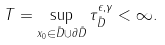<formula> <loc_0><loc_0><loc_500><loc_500>T = \sup _ { x _ { 0 } \in \tilde { D } \cup \partial \tilde { D } } \tau _ { \tilde { D } } ^ { \epsilon , \gamma } < \infty .</formula> 